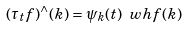<formula> <loc_0><loc_0><loc_500><loc_500>( \tau _ { t } f ) ^ { \wedge } ( k ) = \psi _ { k } ( t ) \ w h f ( k )</formula> 